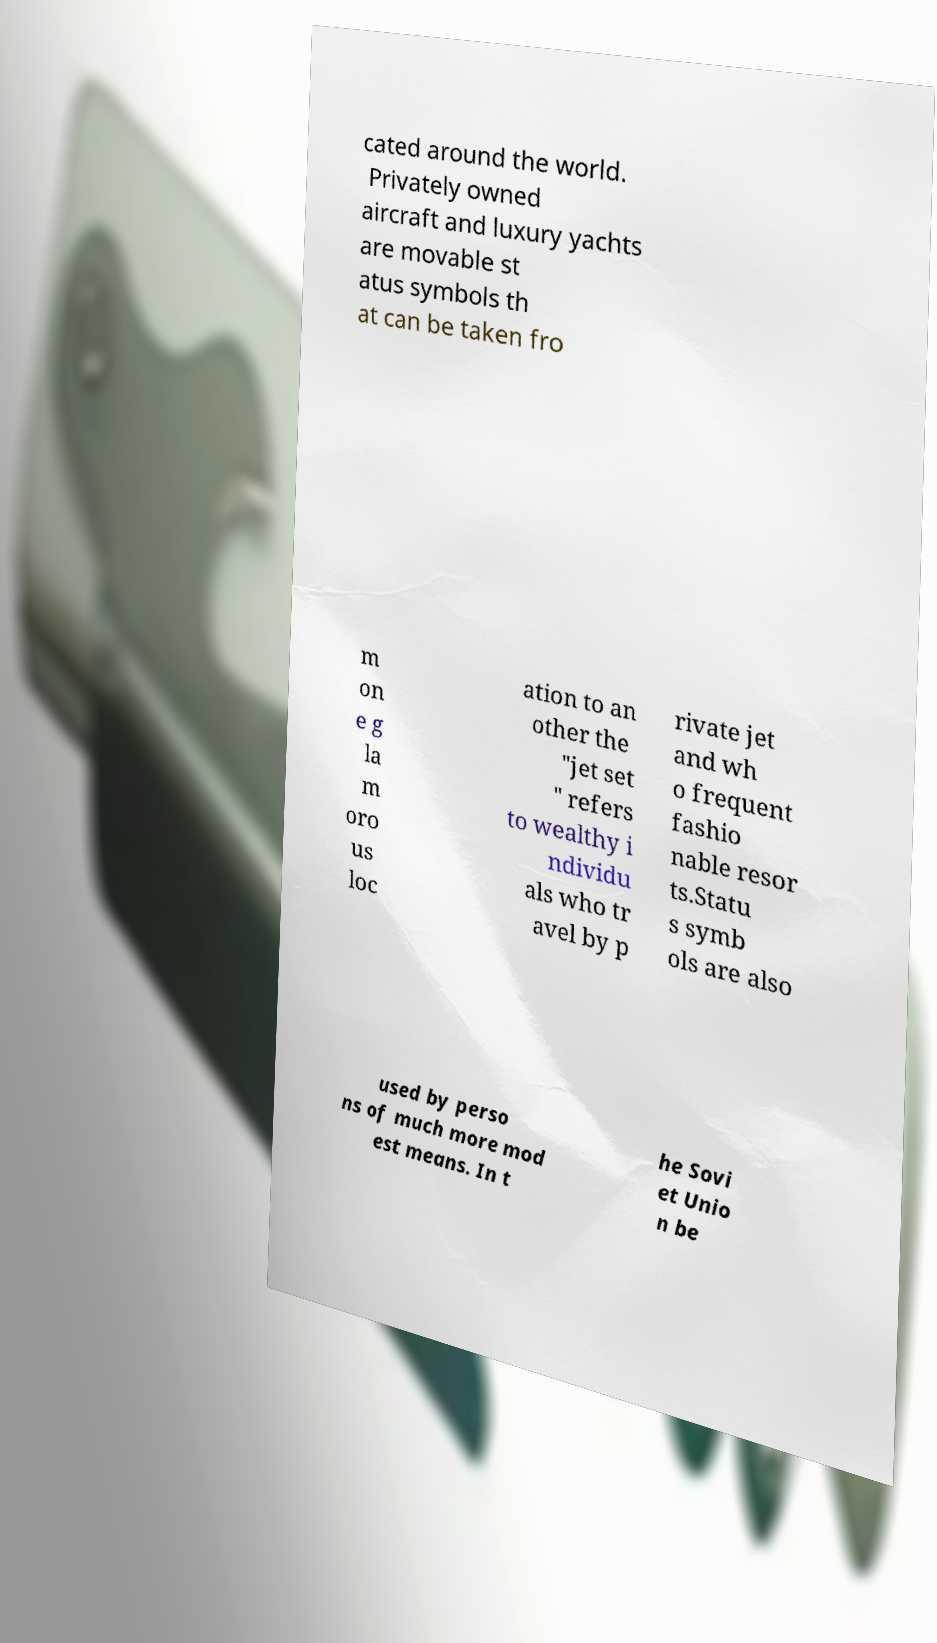Please identify and transcribe the text found in this image. cated around the world. Privately owned aircraft and luxury yachts are movable st atus symbols th at can be taken fro m on e g la m oro us loc ation to an other the "jet set " refers to wealthy i ndividu als who tr avel by p rivate jet and wh o frequent fashio nable resor ts.Statu s symb ols are also used by perso ns of much more mod est means. In t he Sovi et Unio n be 